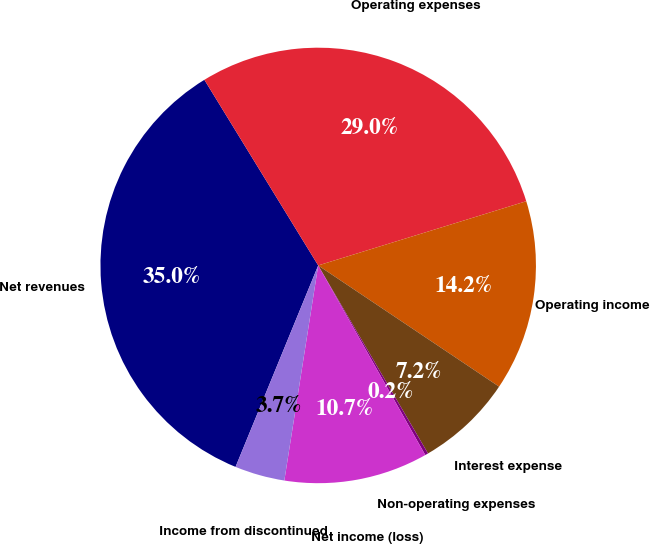Convert chart. <chart><loc_0><loc_0><loc_500><loc_500><pie_chart><fcel>Net revenues<fcel>Operating expenses<fcel>Operating income<fcel>Interest expense<fcel>Non-operating expenses<fcel>Net income (loss)<fcel>Income from discontinued<nl><fcel>35.05%<fcel>28.99%<fcel>14.16%<fcel>7.19%<fcel>0.23%<fcel>10.67%<fcel>3.71%<nl></chart> 